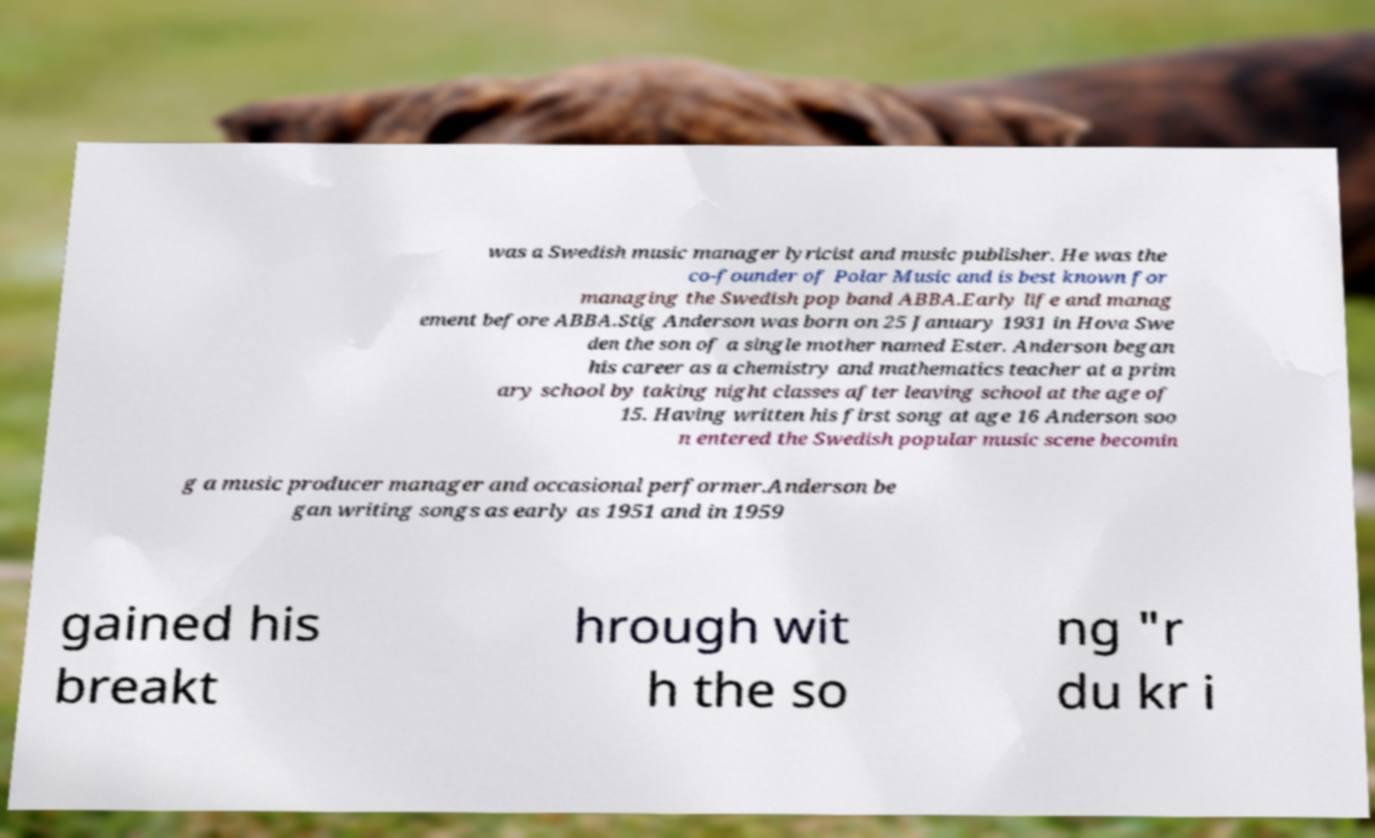What messages or text are displayed in this image? I need them in a readable, typed format. was a Swedish music manager lyricist and music publisher. He was the co-founder of Polar Music and is best known for managing the Swedish pop band ABBA.Early life and manag ement before ABBA.Stig Anderson was born on 25 January 1931 in Hova Swe den the son of a single mother named Ester. Anderson began his career as a chemistry and mathematics teacher at a prim ary school by taking night classes after leaving school at the age of 15. Having written his first song at age 16 Anderson soo n entered the Swedish popular music scene becomin g a music producer manager and occasional performer.Anderson be gan writing songs as early as 1951 and in 1959 gained his breakt hrough wit h the so ng "r du kr i 